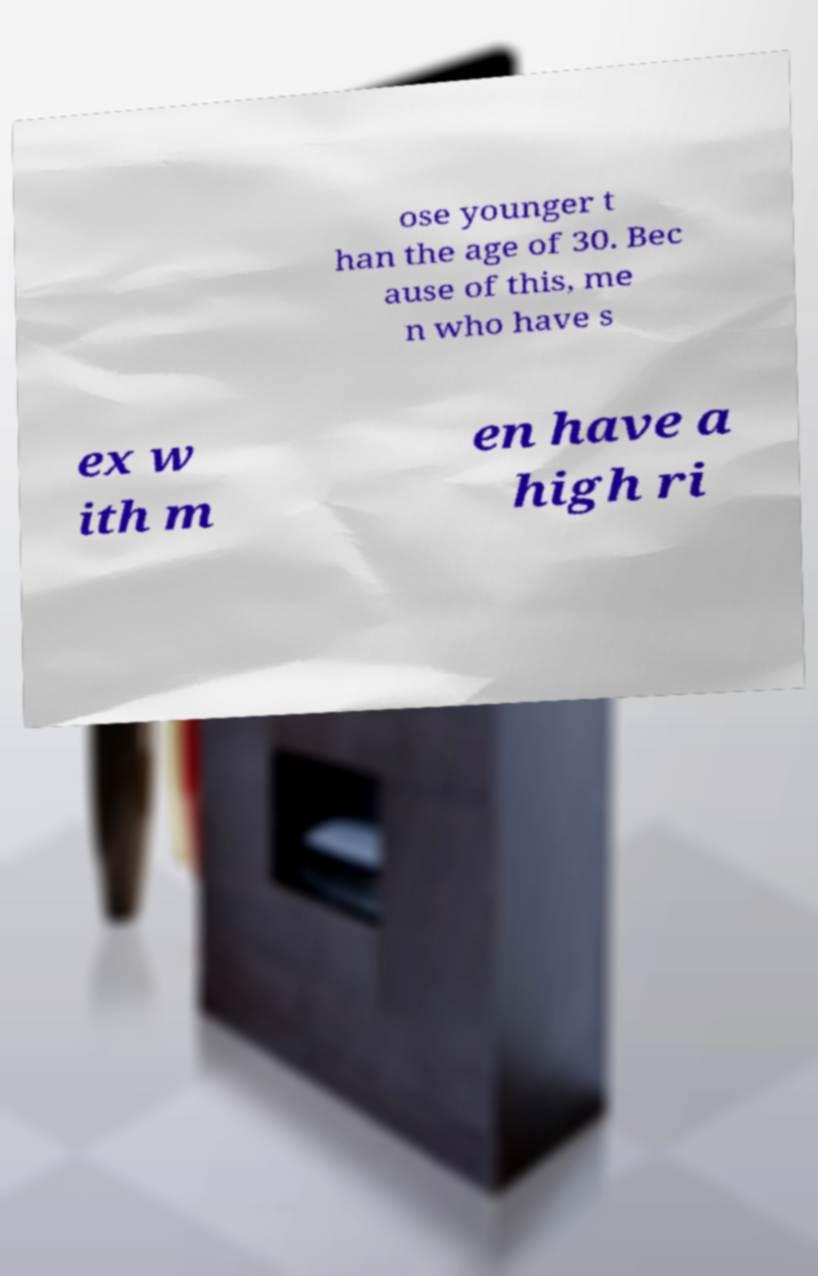For documentation purposes, I need the text within this image transcribed. Could you provide that? ose younger t han the age of 30. Bec ause of this, me n who have s ex w ith m en have a high ri 